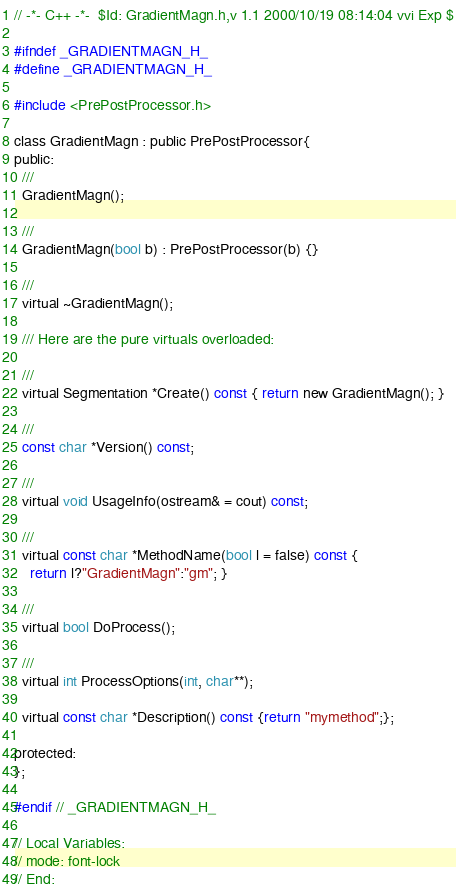<code> <loc_0><loc_0><loc_500><loc_500><_C_>// -*- C++ -*-	$Id: GradientMagn.h,v 1.1 2000/10/19 08:14:04 vvi Exp $

#ifndef _GRADIENTMAGN_H_
#define _GRADIENTMAGN_H_

#include <PrePostProcessor.h>

class GradientMagn : public PrePostProcessor{
public:
  /// 
  GradientMagn();

  /// 
  GradientMagn(bool b) : PrePostProcessor(b) {}

  /// 
  virtual ~GradientMagn();

  /// Here are the pure virtuals overloaded:
  
  ///
  virtual Segmentation *Create() const { return new GradientMagn(); }  

  ///
  const char *Version() const;

  ///
  virtual void UsageInfo(ostream& = cout) const;

  ///
  virtual const char *MethodName(bool l = false) const {
    return l?"GradientMagn":"gm"; }

  ///
  virtual bool DoProcess();

  ///
  virtual int ProcessOptions(int, char**);

  virtual const char *Description() const {return "mymethod";};

protected:
};

#endif // _GRADIENTMAGN_H_

// Local Variables:
// mode: font-lock
// End:
</code> 